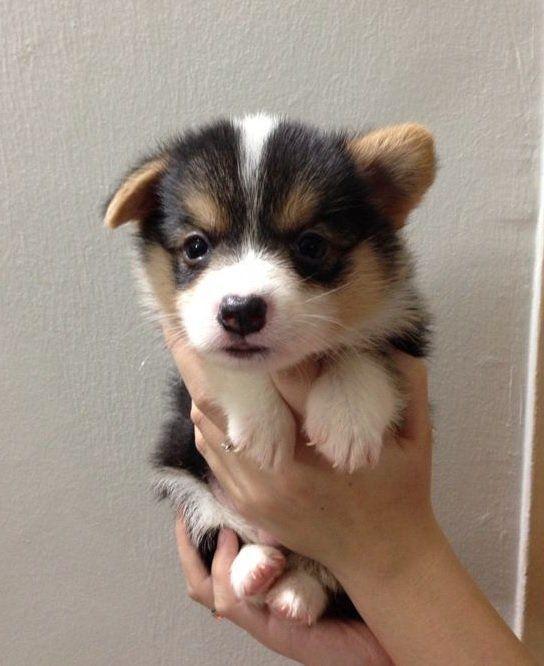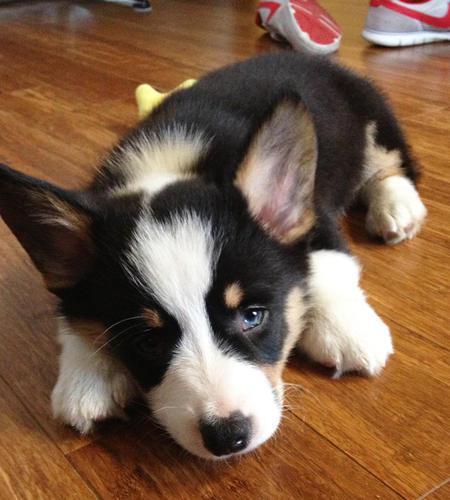The first image is the image on the left, the second image is the image on the right. Given the left and right images, does the statement "At least one dog is showing its tongue." hold true? Answer yes or no. No. The first image is the image on the left, the second image is the image on the right. Assess this claim about the two images: "Both images contain a single camera-facing dog, and both images contain tri-color black, white and tan dogs.". Correct or not? Answer yes or no. Yes. 